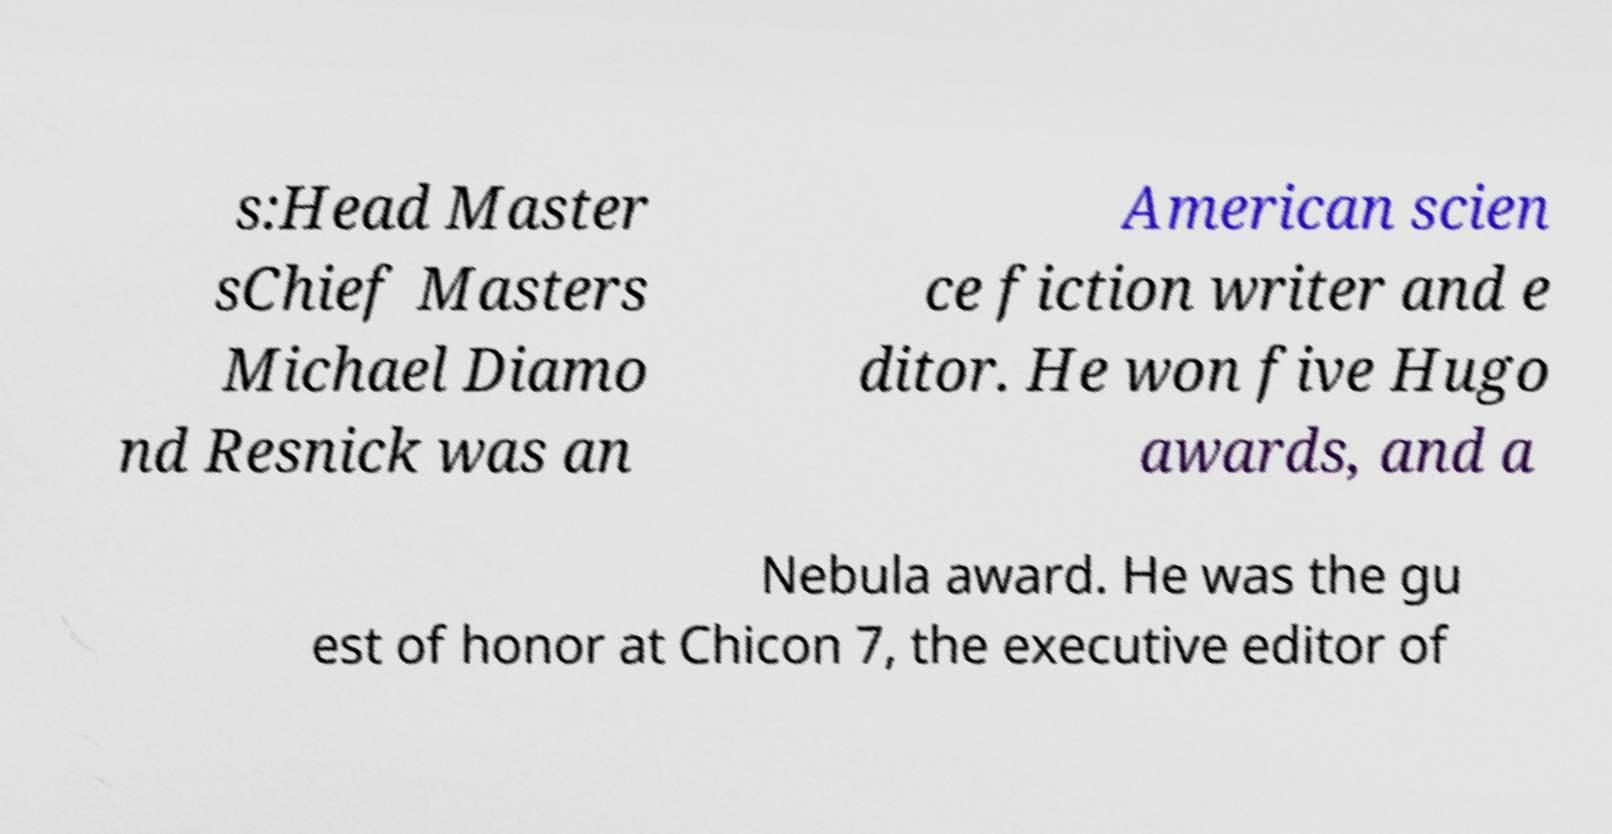Could you extract and type out the text from this image? s:Head Master sChief Masters Michael Diamo nd Resnick was an American scien ce fiction writer and e ditor. He won five Hugo awards, and a Nebula award. He was the gu est of honor at Chicon 7, the executive editor of 